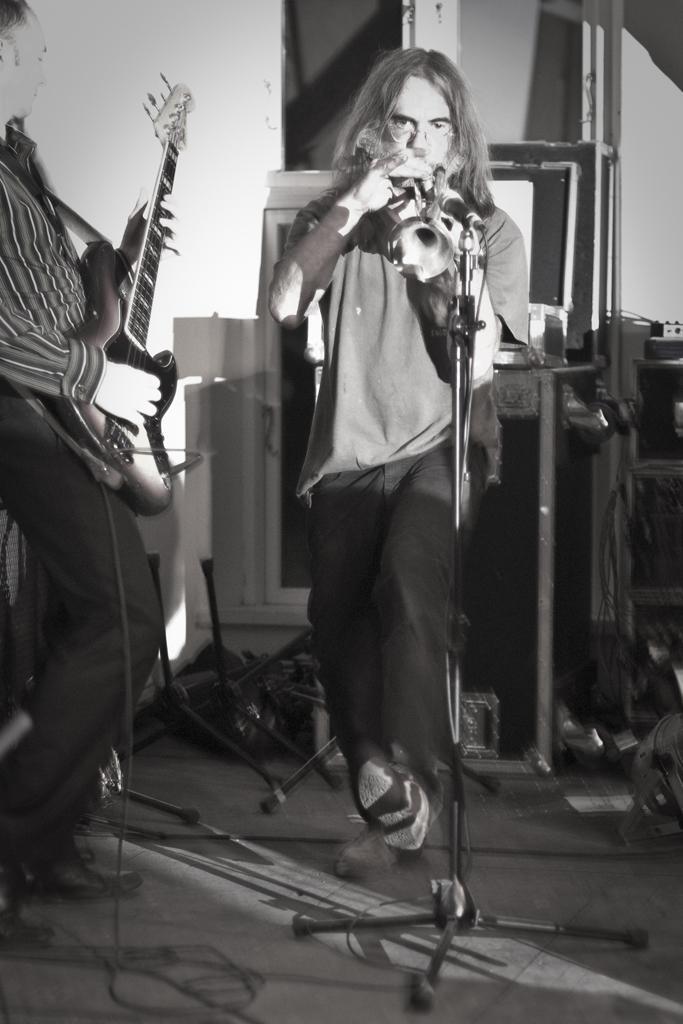In one or two sentences, can you explain what this image depicts? This picture we can see two persons in the left side of the given image a man is playing guitar and in the middle of the image a person is playing musical instrument in front of the microphone,around them we can find musical instruments. 